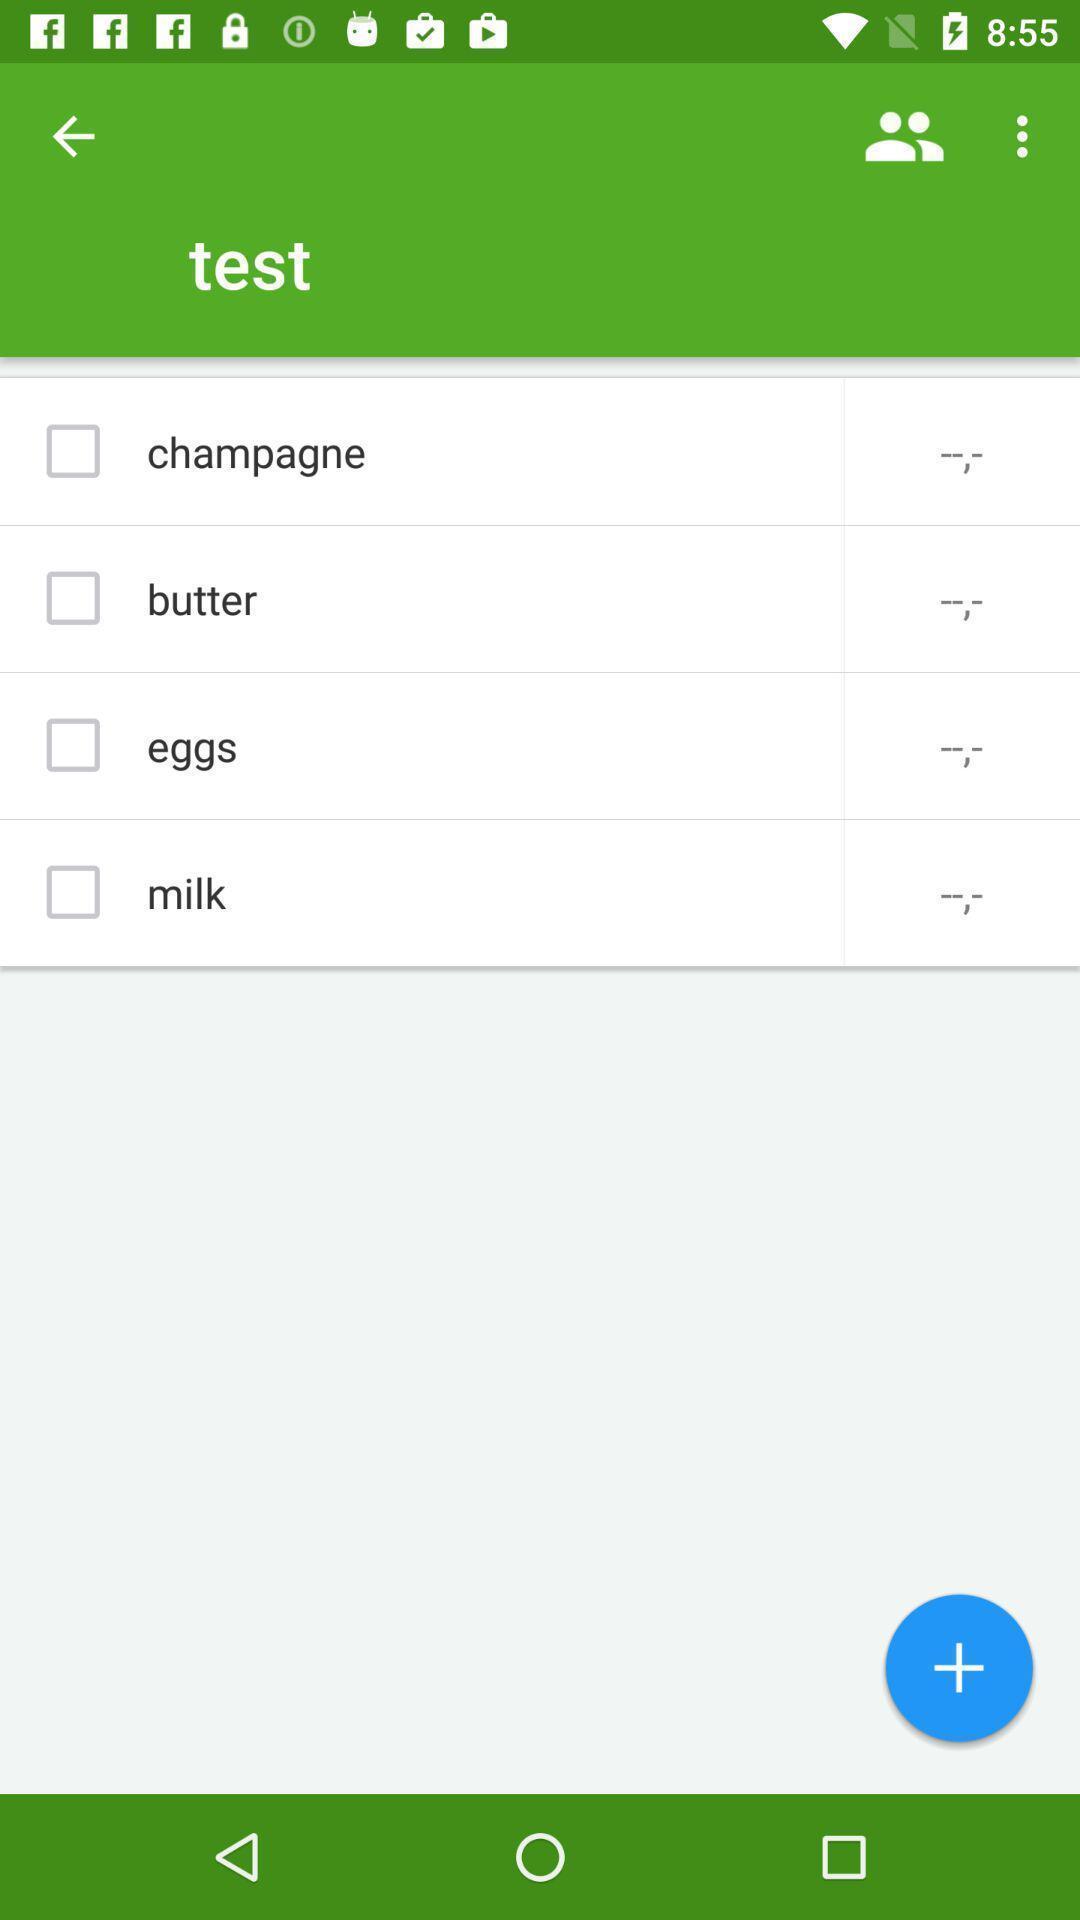What details can you identify in this image? Test page displaying. 